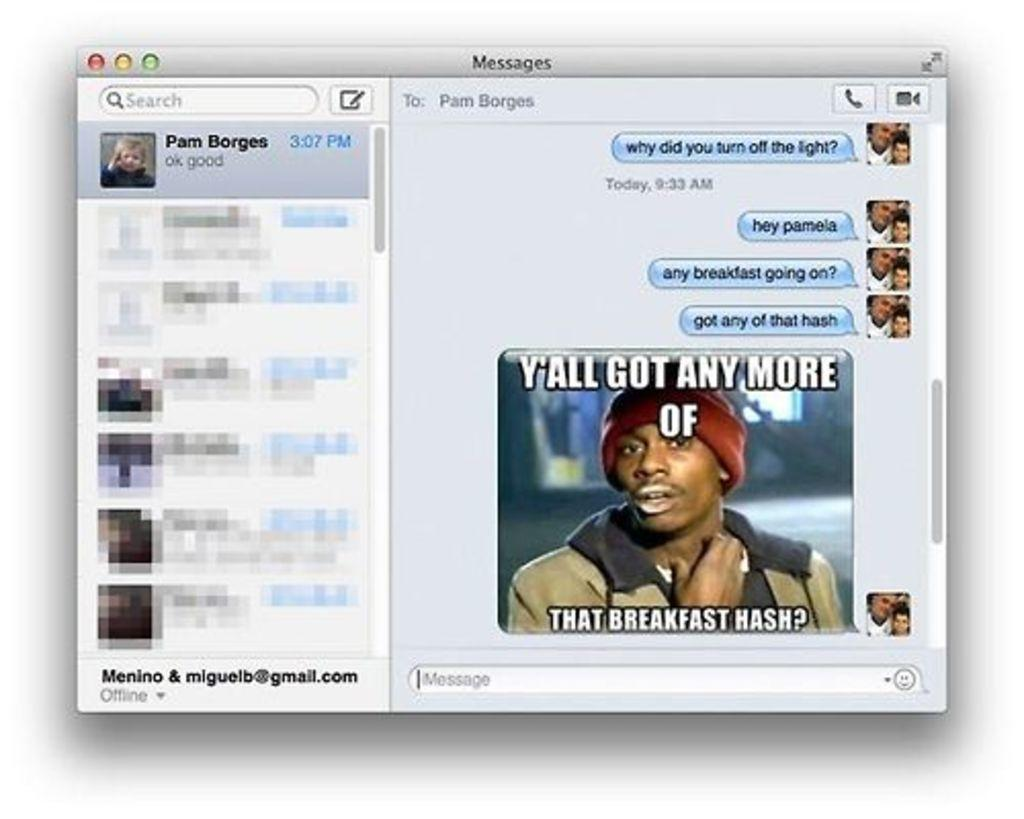What type of images are present in the picture? There are images of people in the picture. Can you describe the man in the picture? The man in the picture is wearing a coat and a cap. What is the purpose of the cursor visible in the picture? The cursor is likely used for interacting with the images or buttons in the picture. What other elements can be seen in the picture? There are buttons present in the picture. Can you see any rocks or cracks in the picture? There are no rocks or cracks visible in the picture, as it is a screenshot of images and buttons. Is there a cobweb present in the picture? There is no cobweb visible in the picture, as it is a digital image with no physical elements. 